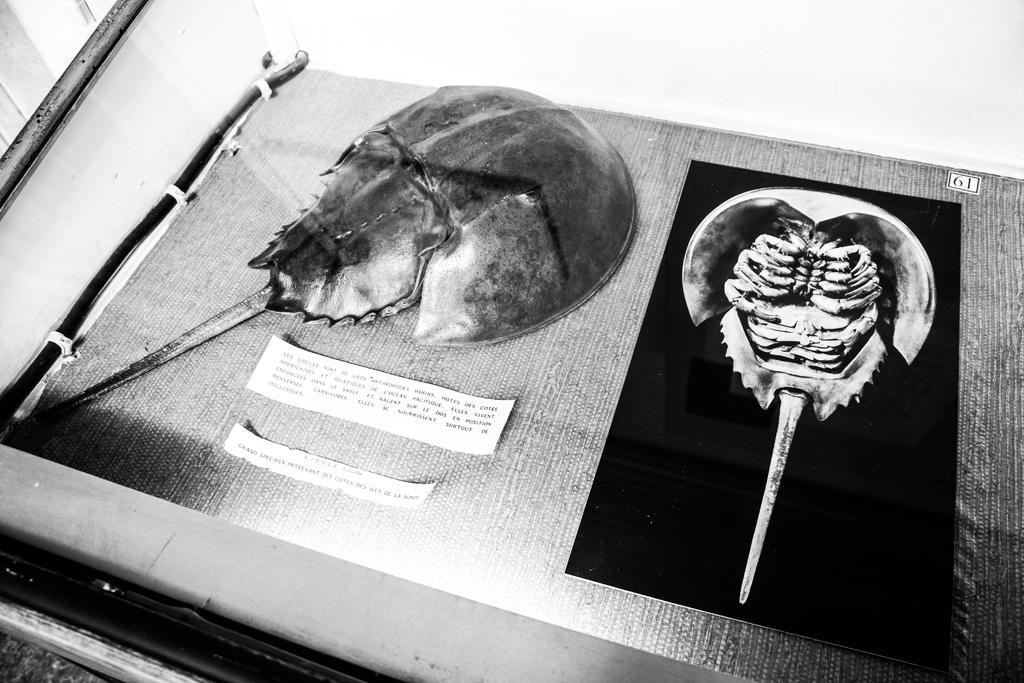In one or two sentences, can you explain what this image depicts? In this image there are few artifacts and labels. 